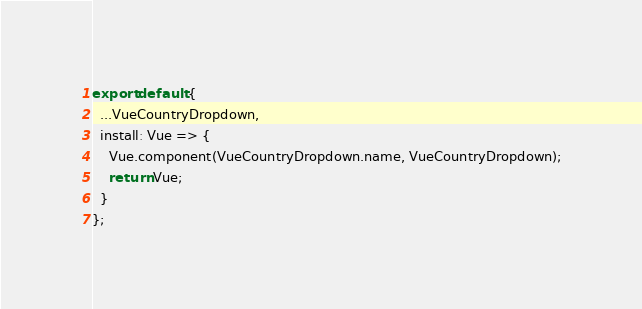<code> <loc_0><loc_0><loc_500><loc_500><_JavaScript_>export default {
  ...VueCountryDropdown,
  install: Vue => {
    Vue.component(VueCountryDropdown.name, VueCountryDropdown);
    return Vue;
  }
};
</code> 